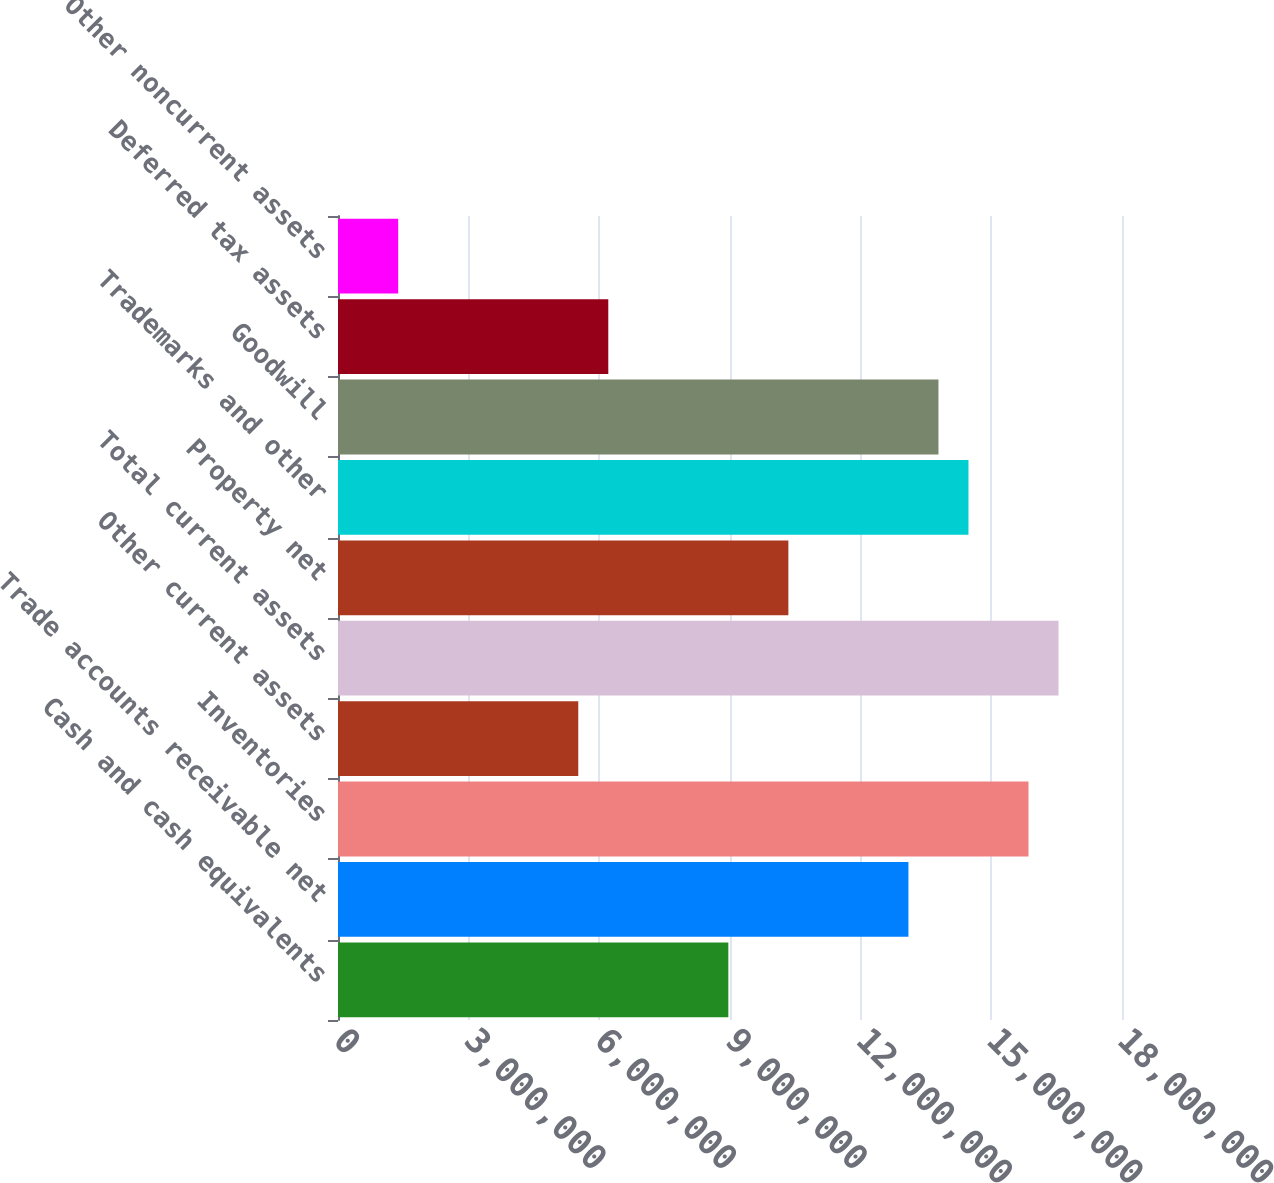Convert chart. <chart><loc_0><loc_0><loc_500><loc_500><bar_chart><fcel>Cash and cash equivalents<fcel>Trade accounts receivable net<fcel>Inventories<fcel>Other current assets<fcel>Total current assets<fcel>Property net<fcel>Trademarks and other<fcel>Goodwill<fcel>Deferred tax assets<fcel>Other noncurrent assets<nl><fcel>8.96213e+06<fcel>1.30968e+07<fcel>1.58533e+07<fcel>5.51654e+06<fcel>1.65424e+07<fcel>1.03404e+07<fcel>1.44751e+07<fcel>1.37859e+07<fcel>6.20566e+06<fcel>1.38184e+06<nl></chart> 